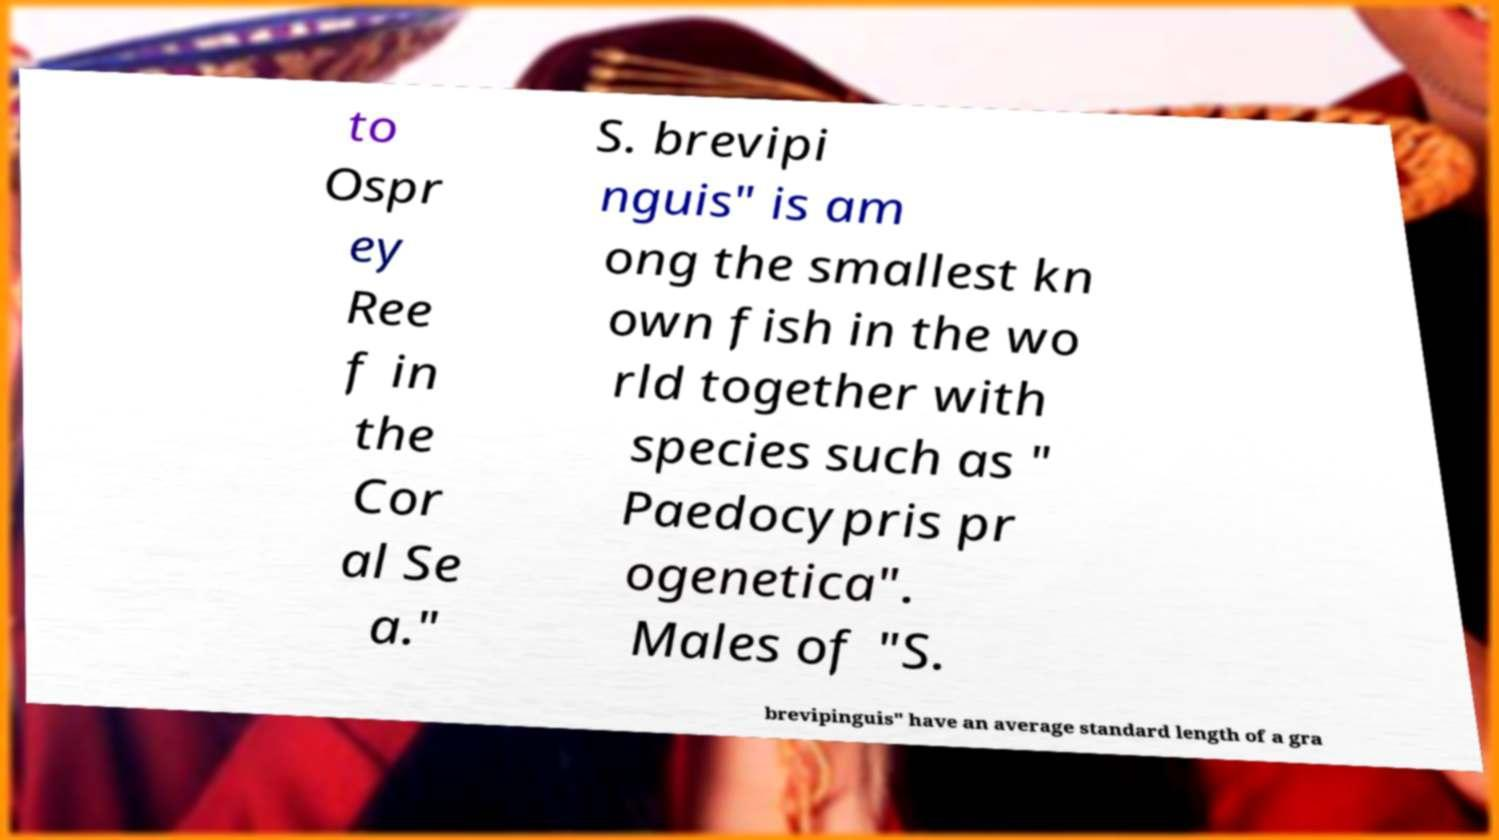Could you assist in decoding the text presented in this image and type it out clearly? to Ospr ey Ree f in the Cor al Se a." S. brevipi nguis" is am ong the smallest kn own fish in the wo rld together with species such as " Paedocypris pr ogenetica". Males of "S. brevipinguis" have an average standard length of a gra 